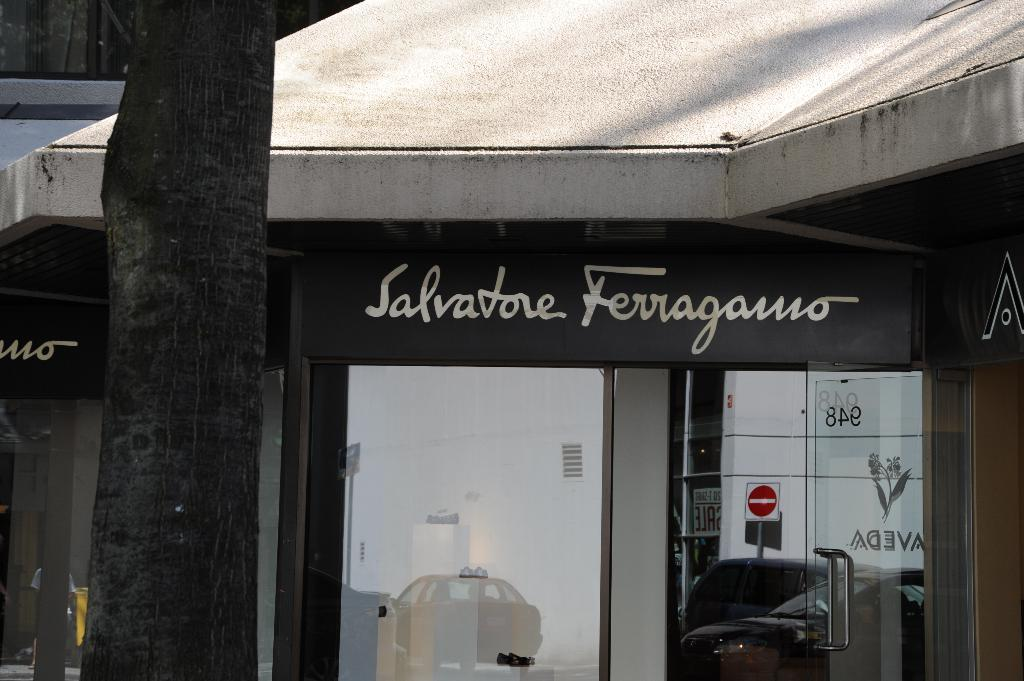What type of structure is visible in the image? There is a building in the image. What can be seen on the signboard of the building? The signboard has text on it. What architectural features are present on the building? The building has windows and a door. What is located in the foreground of the image? There is a tree in the foreground of the image. Can you tell me how many quills are sticking out of the tree in the image? There are no quills present in the image; it features a tree in the foreground. Is there a beggar sitting on the sidewalk in front of the building? There is no mention of a beggar or a sidewalk in the provided facts, so we cannot answer that question. 